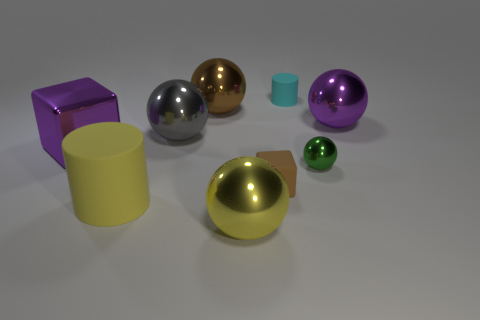There is a ball that is the same color as the shiny block; what material is it?
Your response must be concise. Metal. What is the material of the big purple thing that is the same shape as the brown matte object?
Provide a succinct answer. Metal. What number of other objects are there of the same shape as the tiny cyan thing?
Offer a terse response. 1. Is the material of the purple thing that is on the left side of the tiny matte cylinder the same as the gray thing?
Offer a terse response. Yes. Are there an equal number of cylinders that are in front of the large yellow rubber object and big shiny objects that are in front of the matte cube?
Ensure brevity in your answer.  No. How big is the object on the left side of the large matte thing?
Ensure brevity in your answer.  Large. Is there a big brown sphere that has the same material as the green sphere?
Your response must be concise. Yes. Is the color of the metallic ball in front of the tiny brown object the same as the tiny metal thing?
Provide a succinct answer. No. Is the number of yellow cylinders left of the large purple block the same as the number of yellow rubber objects?
Make the answer very short. No. Are there any big metallic spheres that have the same color as the big cylinder?
Keep it short and to the point. Yes. 